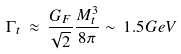Convert formula to latex. <formula><loc_0><loc_0><loc_500><loc_500>\Gamma _ { t } \, \approx \, \frac { G _ { F } } { \sqrt { 2 } } \frac { M _ { t } ^ { 3 } } { 8 \pi } \sim \, 1 . 5 G e V</formula> 